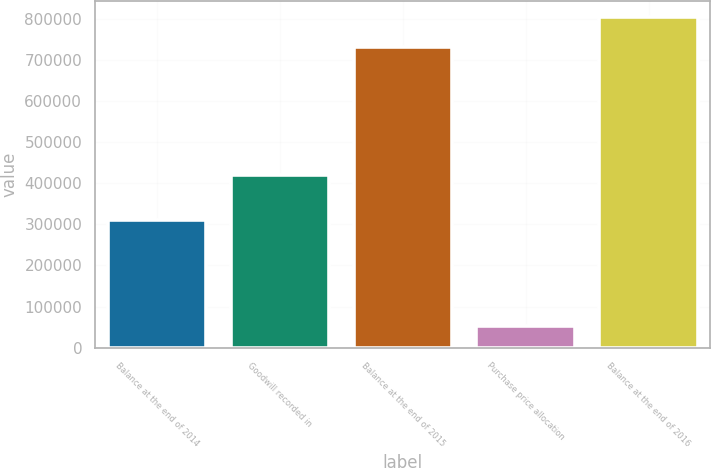<chart> <loc_0><loc_0><loc_500><loc_500><bar_chart><fcel>Balance at the end of 2014<fcel>Goodwill recorded in<fcel>Balance at the end of 2015<fcel>Purchase price allocation<fcel>Balance at the end of 2016<nl><fcel>311170<fcel>419667<fcel>730837<fcel>51827<fcel>803921<nl></chart> 